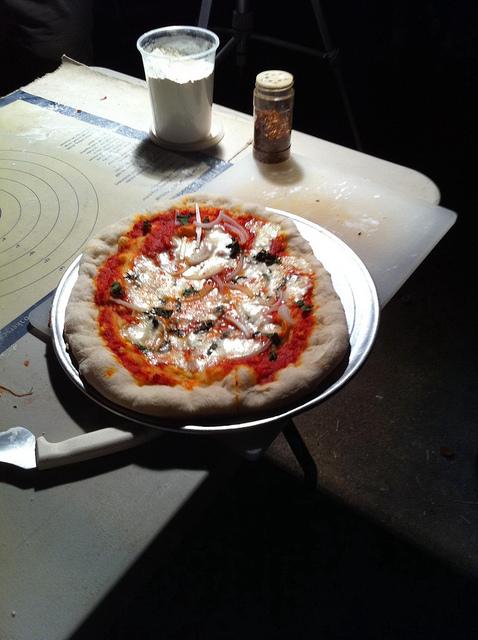Is the pizza hot?
Short answer required. Yes. Is the cup full of flour?
Quick response, please. Yes. Is this a pesto pizza?
Give a very brief answer. No. 